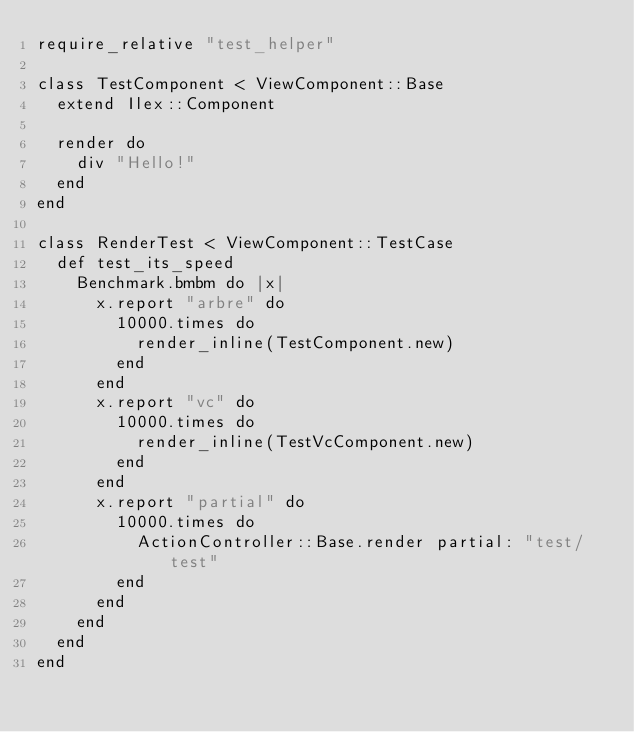<code> <loc_0><loc_0><loc_500><loc_500><_Ruby_>require_relative "test_helper"

class TestComponent < ViewComponent::Base
  extend Ilex::Component

  render do
    div "Hello!"
  end
end

class RenderTest < ViewComponent::TestCase
  def test_its_speed
    Benchmark.bmbm do |x|
      x.report "arbre" do
        10000.times do
          render_inline(TestComponent.new)
        end
      end
      x.report "vc" do
        10000.times do
          render_inline(TestVcComponent.new)
        end
      end
      x.report "partial" do
        10000.times do
          ActionController::Base.render partial: "test/test"
        end
      end
    end
  end
end
</code> 